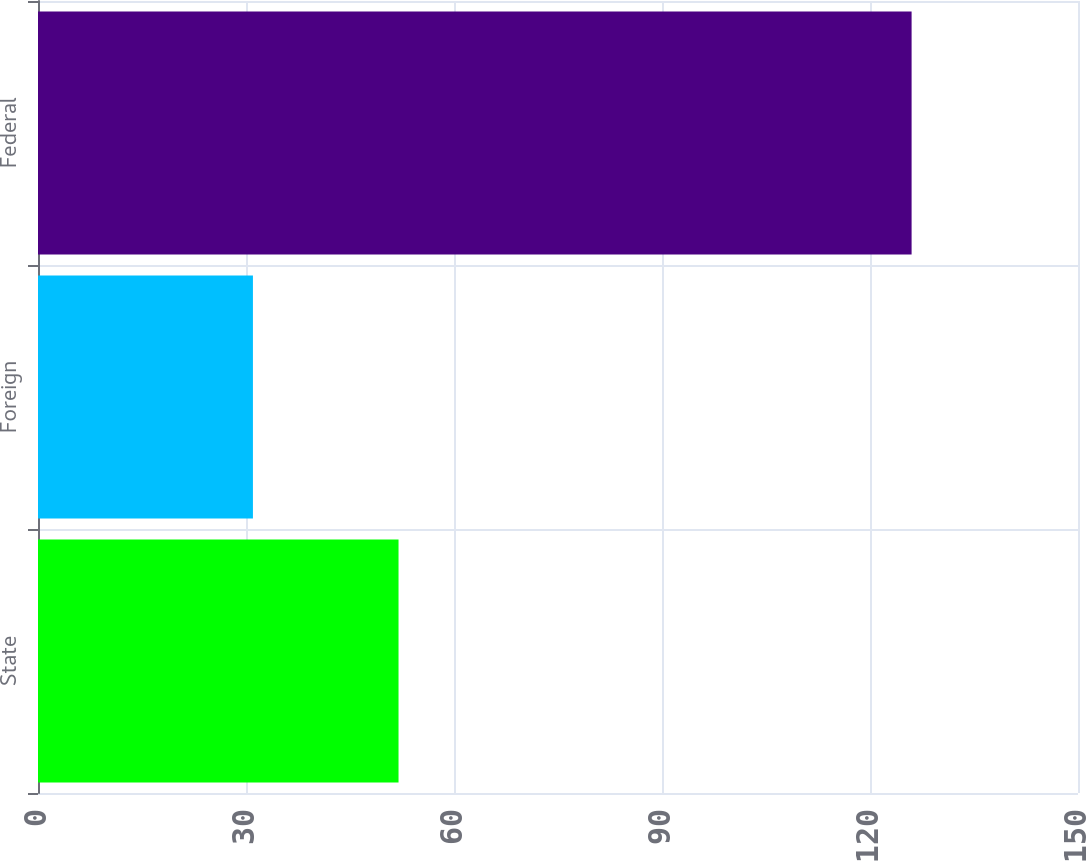<chart> <loc_0><loc_0><loc_500><loc_500><bar_chart><fcel>State<fcel>Foreign<fcel>Federal<nl><fcel>52<fcel>31<fcel>126<nl></chart> 